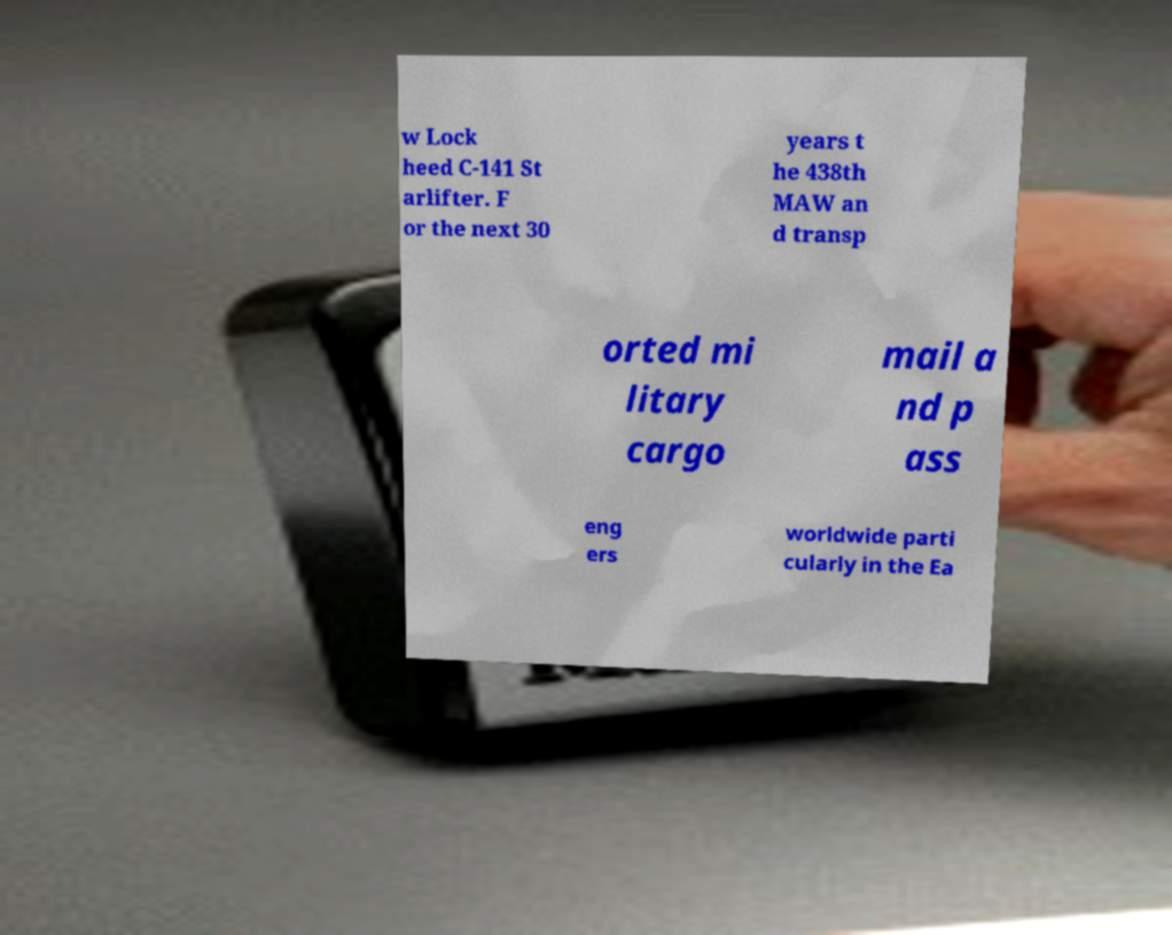Can you accurately transcribe the text from the provided image for me? w Lock heed C-141 St arlifter. F or the next 30 years t he 438th MAW an d transp orted mi litary cargo mail a nd p ass eng ers worldwide parti cularly in the Ea 